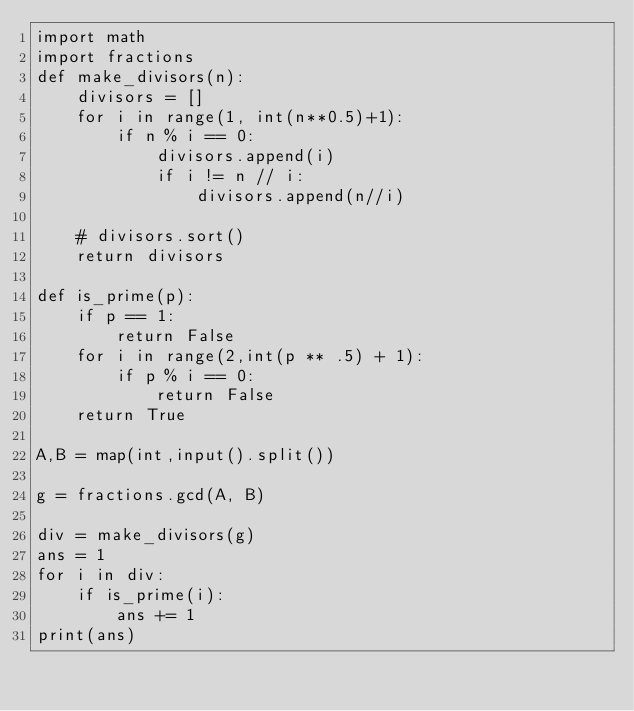Convert code to text. <code><loc_0><loc_0><loc_500><loc_500><_Python_>import math
import fractions
def make_divisors(n):
    divisors = []
    for i in range(1, int(n**0.5)+1):
        if n % i == 0:
            divisors.append(i)
            if i != n // i:
                divisors.append(n//i)

    # divisors.sort()
    return divisors

def is_prime(p):
    if p == 1:
        return False
    for i in range(2,int(p ** .5) + 1):
        if p % i == 0:
            return False
    return True

A,B = map(int,input().split())

g = fractions.gcd(A, B)

div = make_divisors(g)
ans = 1
for i in div:
    if is_prime(i):
        ans += 1
print(ans)</code> 